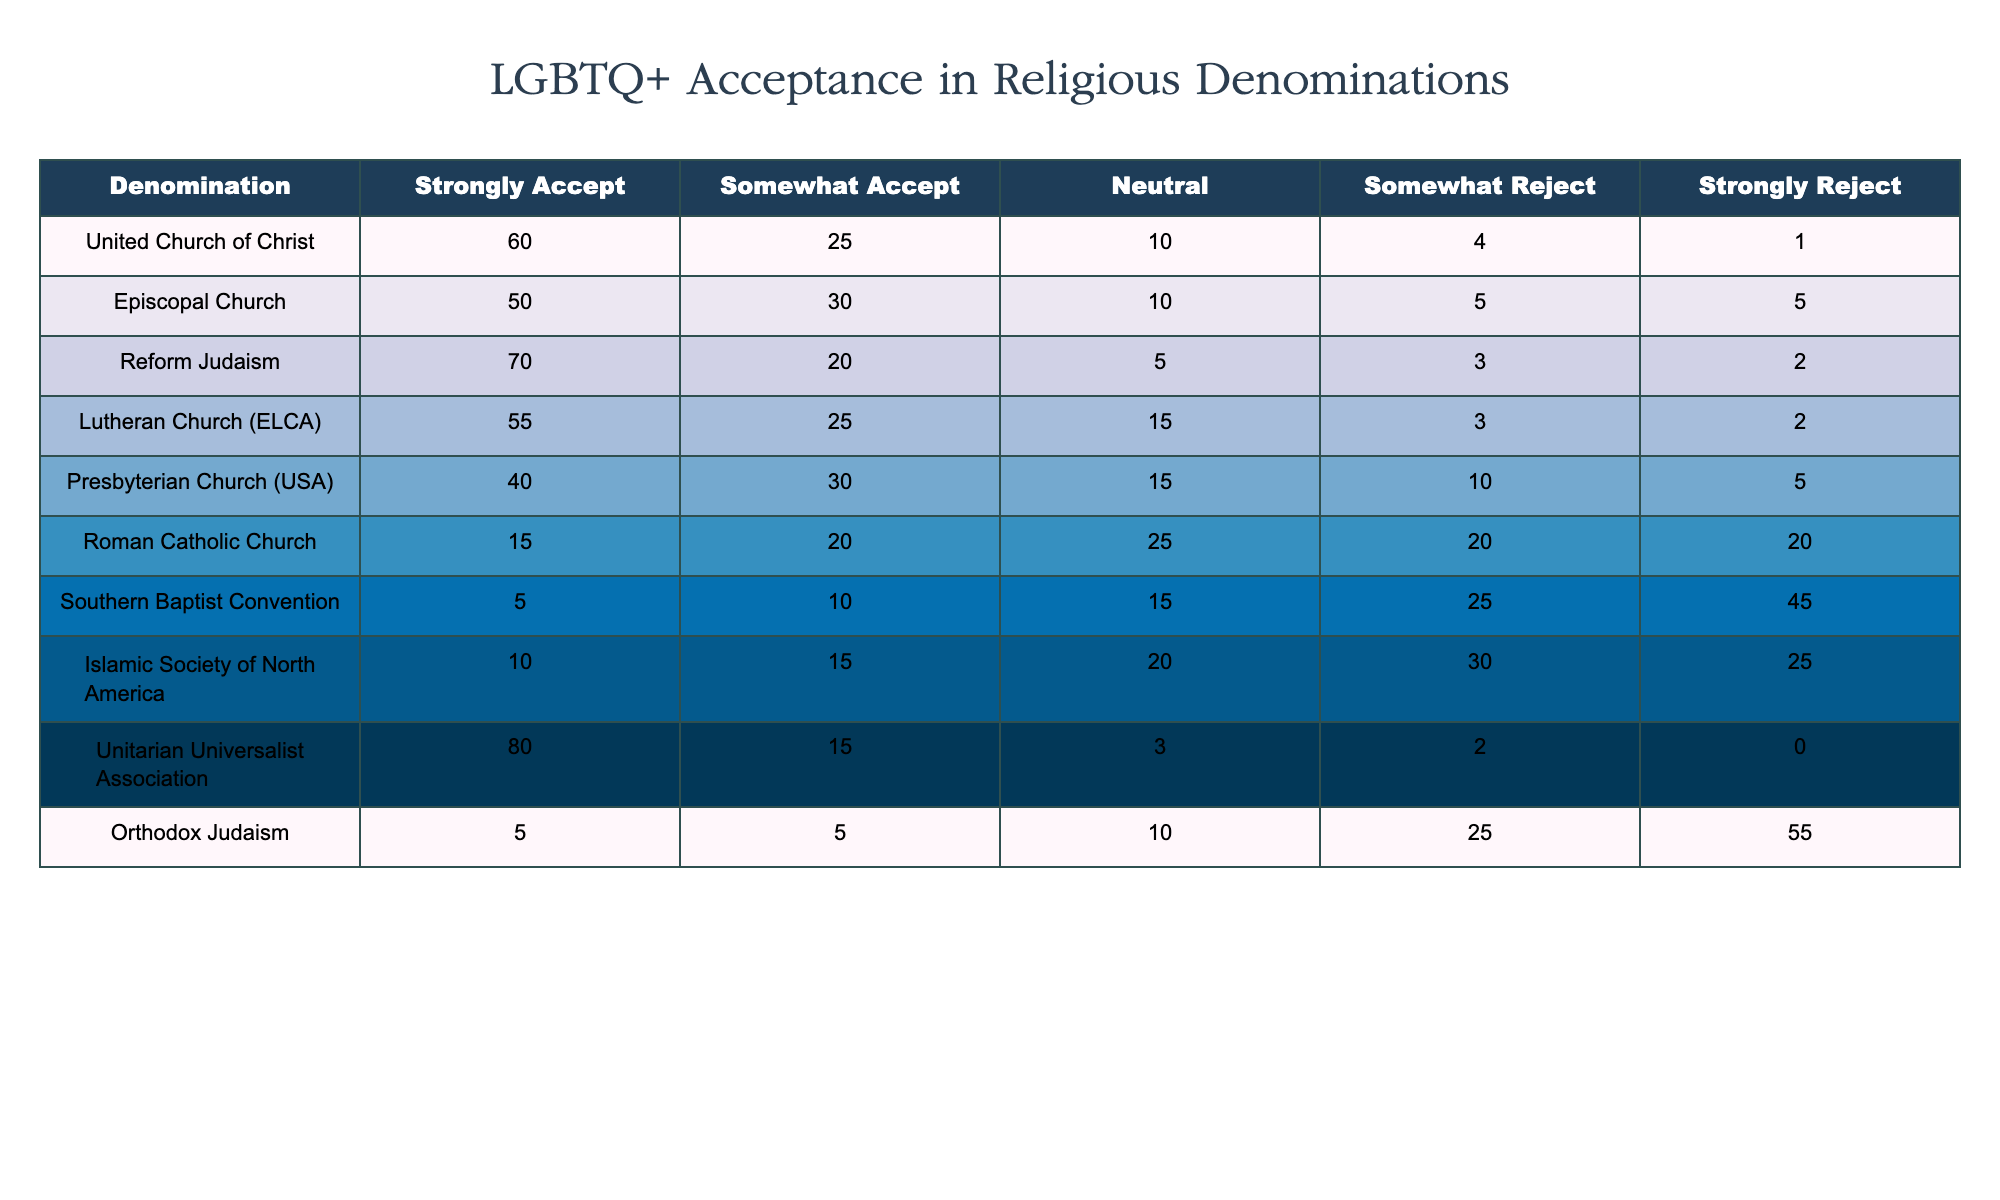What percentage of the United Church of Christ strongly accepts LGBTQ+ individuals? The data for the United Church of Christ shows that 60 individuals strongly accept LGBTQ+ individuals. To find the percentage, this number is simply stated as it directly reflects the total acceptance values provided.
Answer: 60% Which denomination has the lowest number of respondents who strongly accept LGBTQ+ individuals? By comparing the values for "Strongly Accept" across all denominations, the Southern Baptist Convention has the lowest number, at 5 individuals.
Answer: Southern Baptist Convention What is the total percentage of acceptance (strongly accept + somewhat accept) for the Episcopal Church? For the Episcopal Church, the values are 50 (strongly accept) and 30 (somewhat accept). To calculate the total acceptance percentage, we sum these values: 50 + 30 = 80. Therefore, the total acceptance percentage is 80%.
Answer: 80% Is it true that Orthodox Judaism has a higher percentage of individuals who strongly reject LGBTQ+ than those who strongly accept? The values for Orthodox Judaism show that 5 individuals strongly accept and 55 individuals strongly reject. Since 55 is greater than 5, the statement is true.
Answer: Yes What is the average number of individuals who somewhat accept LGBTQ+ across all denominations? To get the average, we calculate the total number of individuals who somewhat accept and divide by the number of denominations: Total somewhat accept is 25 (UCC) + 30 (Episcopal) + 20 (Reform) + 25 (Lutheran) + 30 (Presbyterian) + 20 (Catholic) + 10 (SBC) + 15 (Islamic) + 15 (UUA) + 5 (Orthodox) =  5 + 10 + 15 + 20 + 15 + 20 + 25 + 30 + 30 + 25 =  15 + 80 + 20 =  30 + 25 =  15 + 25 =  30 = 30. The average is 30 / 10 = 26.
Answer: 26 Which denomination shows the highest acceptance for LGBTQ+ individuals? By reviewing the "Strongly Accept" values, Unitarian Universalist Association has the highest number at 80 individuals, indicating it has the highest acceptance.
Answer: Unitarian Universalist Association 